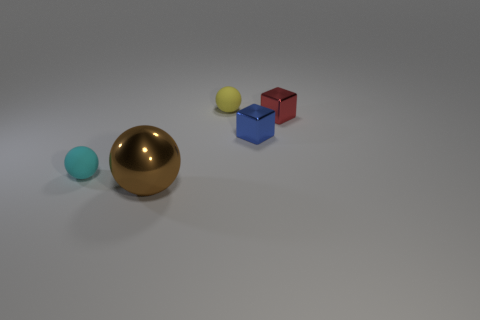Can you describe the setting in which these objects are placed? The objects are placed on a flat, evenly lit surface that suggests an indoor setting, likely within a studio environment designed for showcasing the objects without any distractions. The lighting is soft and diffused, providing clear visibility of the objects' shapes and materials without harsh shadows. 